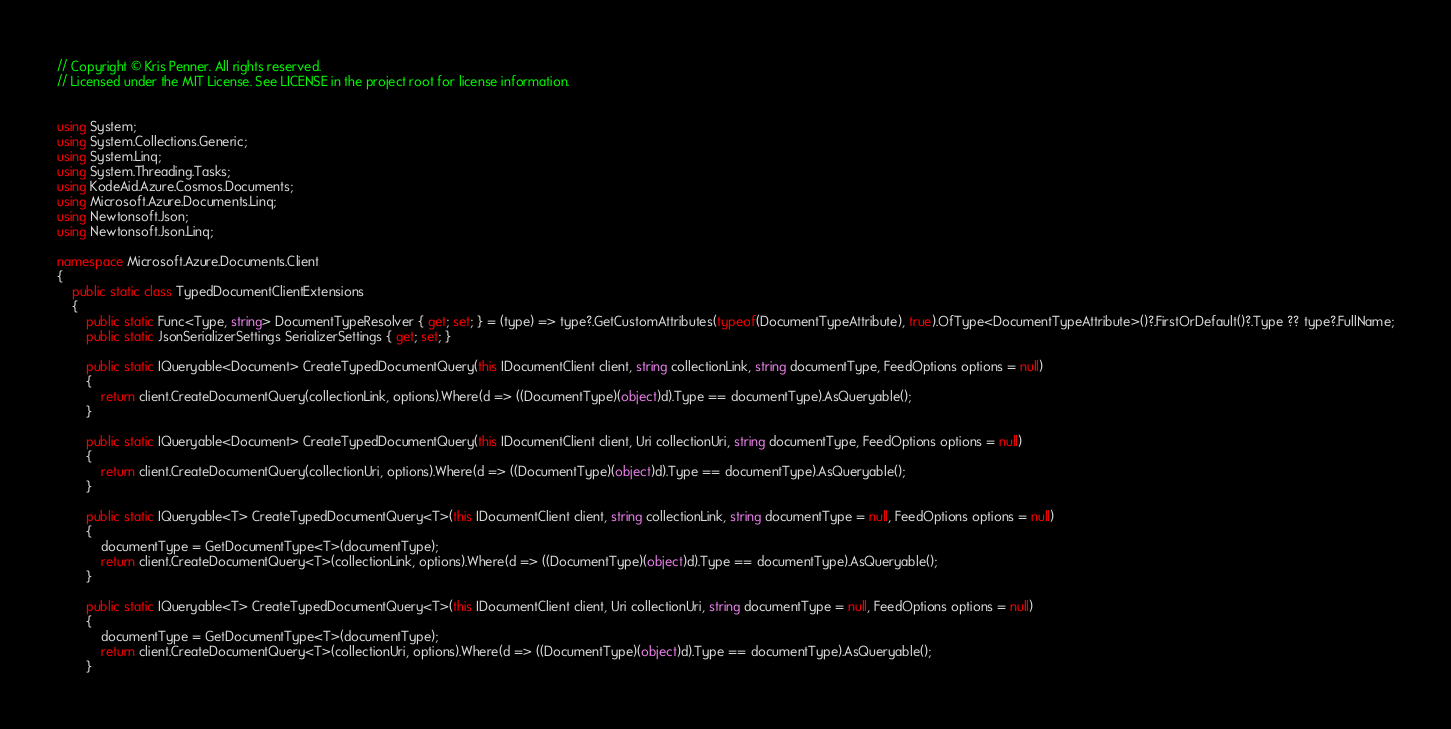Convert code to text. <code><loc_0><loc_0><loc_500><loc_500><_C#_>// Copyright © Kris Penner. All rights reserved.
// Licensed under the MIT License. See LICENSE in the project root for license information.


using System;
using System.Collections.Generic;
using System.Linq;
using System.Threading.Tasks;
using KodeAid.Azure.Cosmos.Documents;
using Microsoft.Azure.Documents.Linq;
using Newtonsoft.Json;
using Newtonsoft.Json.Linq;

namespace Microsoft.Azure.Documents.Client
{
    public static class TypedDocumentClientExtensions
    {
        public static Func<Type, string> DocumentTypeResolver { get; set; } = (type) => type?.GetCustomAttributes(typeof(DocumentTypeAttribute), true).OfType<DocumentTypeAttribute>()?.FirstOrDefault()?.Type ?? type?.FullName;
        public static JsonSerializerSettings SerializerSettings { get; set; }

        public static IQueryable<Document> CreateTypedDocumentQuery(this IDocumentClient client, string collectionLink, string documentType, FeedOptions options = null)
        {
            return client.CreateDocumentQuery(collectionLink, options).Where(d => ((DocumentType)(object)d).Type == documentType).AsQueryable();
        }

        public static IQueryable<Document> CreateTypedDocumentQuery(this IDocumentClient client, Uri collectionUri, string documentType, FeedOptions options = null)
        {
            return client.CreateDocumentQuery(collectionUri, options).Where(d => ((DocumentType)(object)d).Type == documentType).AsQueryable();
        }

        public static IQueryable<T> CreateTypedDocumentQuery<T>(this IDocumentClient client, string collectionLink, string documentType = null, FeedOptions options = null)
        {
            documentType = GetDocumentType<T>(documentType);
            return client.CreateDocumentQuery<T>(collectionLink, options).Where(d => ((DocumentType)(object)d).Type == documentType).AsQueryable();
        }

        public static IQueryable<T> CreateTypedDocumentQuery<T>(this IDocumentClient client, Uri collectionUri, string documentType = null, FeedOptions options = null)
        {
            documentType = GetDocumentType<T>(documentType);
            return client.CreateDocumentQuery<T>(collectionUri, options).Where(d => ((DocumentType)(object)d).Type == documentType).AsQueryable();
        }
</code> 